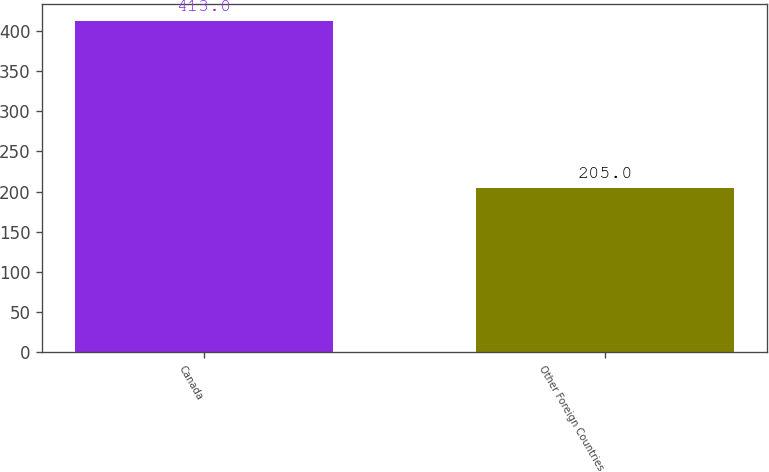Convert chart to OTSL. <chart><loc_0><loc_0><loc_500><loc_500><bar_chart><fcel>Canada<fcel>Other Foreign Countries<nl><fcel>413<fcel>205<nl></chart> 